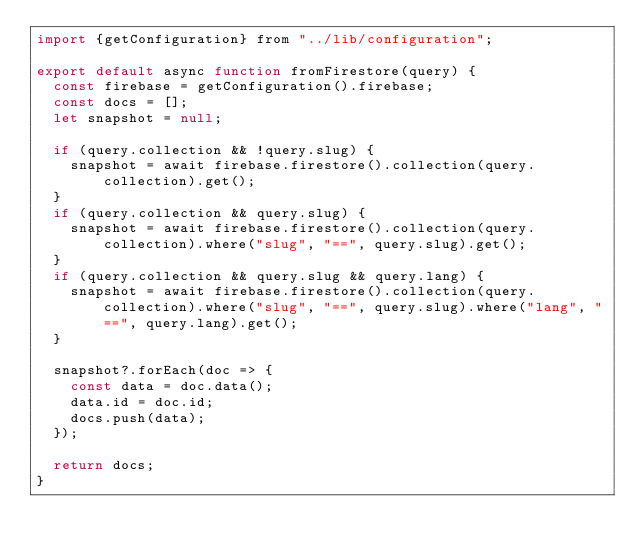Convert code to text. <code><loc_0><loc_0><loc_500><loc_500><_JavaScript_>import {getConfiguration} from "../lib/configuration";

export default async function fromFirestore(query) {
  const firebase = getConfiguration().firebase;
  const docs = [];
  let snapshot = null;

  if (query.collection && !query.slug) {
    snapshot = await firebase.firestore().collection(query.collection).get();
  }
  if (query.collection && query.slug) {
    snapshot = await firebase.firestore().collection(query.collection).where("slug", "==", query.slug).get();
  }
  if (query.collection && query.slug && query.lang) {
    snapshot = await firebase.firestore().collection(query.collection).where("slug", "==", query.slug).where("lang", "==", query.lang).get();
  }

  snapshot?.forEach(doc => {
    const data = doc.data();
    data.id = doc.id;
    docs.push(data);
  });

  return docs;
}
</code> 